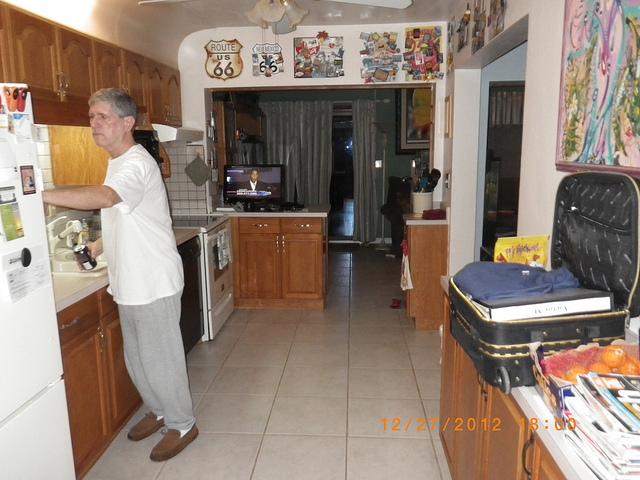Where is route 66?
Keep it brief. On wall. Who is wearing slippers?
Write a very short answer. Man. How many people are present?
Write a very short answer. 1. 